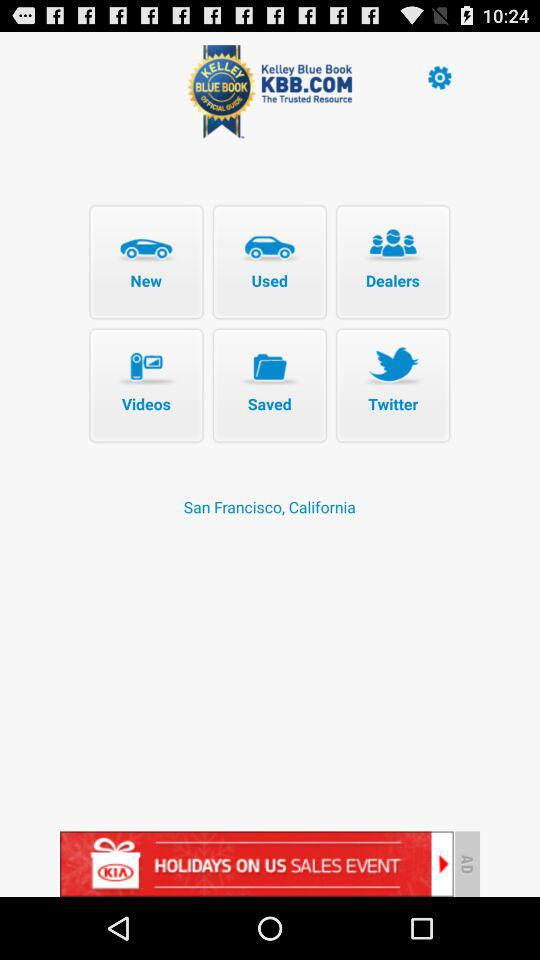What is the application name? The application name is "KBB.com - New & Used Car Price". 